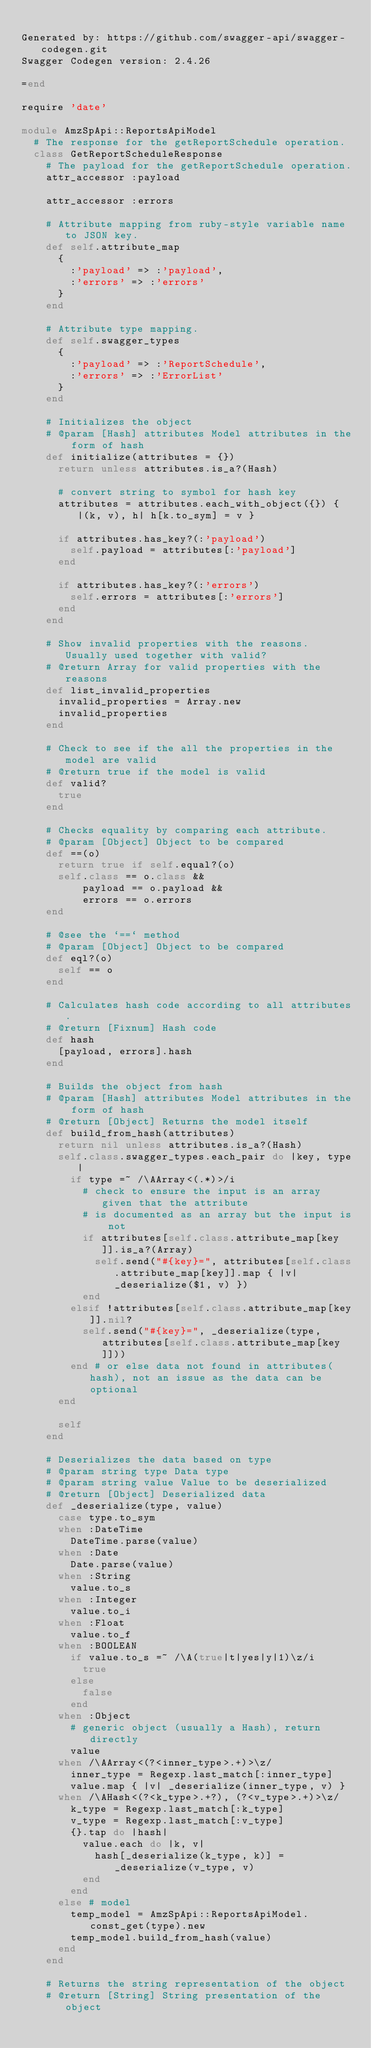Convert code to text. <code><loc_0><loc_0><loc_500><loc_500><_Ruby_>
Generated by: https://github.com/swagger-api/swagger-codegen.git
Swagger Codegen version: 2.4.26

=end

require 'date'

module AmzSpApi::ReportsApiModel
  # The response for the getReportSchedule operation.
  class GetReportScheduleResponse
    # The payload for the getReportSchedule operation.
    attr_accessor :payload

    attr_accessor :errors

    # Attribute mapping from ruby-style variable name to JSON key.
    def self.attribute_map
      {
        :'payload' => :'payload',
        :'errors' => :'errors'
      }
    end

    # Attribute type mapping.
    def self.swagger_types
      {
        :'payload' => :'ReportSchedule',
        :'errors' => :'ErrorList'
      }
    end

    # Initializes the object
    # @param [Hash] attributes Model attributes in the form of hash
    def initialize(attributes = {})
      return unless attributes.is_a?(Hash)

      # convert string to symbol for hash key
      attributes = attributes.each_with_object({}) { |(k, v), h| h[k.to_sym] = v }

      if attributes.has_key?(:'payload')
        self.payload = attributes[:'payload']
      end

      if attributes.has_key?(:'errors')
        self.errors = attributes[:'errors']
      end
    end

    # Show invalid properties with the reasons. Usually used together with valid?
    # @return Array for valid properties with the reasons
    def list_invalid_properties
      invalid_properties = Array.new
      invalid_properties
    end

    # Check to see if the all the properties in the model are valid
    # @return true if the model is valid
    def valid?
      true
    end

    # Checks equality by comparing each attribute.
    # @param [Object] Object to be compared
    def ==(o)
      return true if self.equal?(o)
      self.class == o.class &&
          payload == o.payload &&
          errors == o.errors
    end

    # @see the `==` method
    # @param [Object] Object to be compared
    def eql?(o)
      self == o
    end

    # Calculates hash code according to all attributes.
    # @return [Fixnum] Hash code
    def hash
      [payload, errors].hash
    end

    # Builds the object from hash
    # @param [Hash] attributes Model attributes in the form of hash
    # @return [Object] Returns the model itself
    def build_from_hash(attributes)
      return nil unless attributes.is_a?(Hash)
      self.class.swagger_types.each_pair do |key, type|
        if type =~ /\AArray<(.*)>/i
          # check to ensure the input is an array given that the attribute
          # is documented as an array but the input is not
          if attributes[self.class.attribute_map[key]].is_a?(Array)
            self.send("#{key}=", attributes[self.class.attribute_map[key]].map { |v| _deserialize($1, v) })
          end
        elsif !attributes[self.class.attribute_map[key]].nil?
          self.send("#{key}=", _deserialize(type, attributes[self.class.attribute_map[key]]))
        end # or else data not found in attributes(hash), not an issue as the data can be optional
      end

      self
    end

    # Deserializes the data based on type
    # @param string type Data type
    # @param string value Value to be deserialized
    # @return [Object] Deserialized data
    def _deserialize(type, value)
      case type.to_sym
      when :DateTime
        DateTime.parse(value)
      when :Date
        Date.parse(value)
      when :String
        value.to_s
      when :Integer
        value.to_i
      when :Float
        value.to_f
      when :BOOLEAN
        if value.to_s =~ /\A(true|t|yes|y|1)\z/i
          true
        else
          false
        end
      when :Object
        # generic object (usually a Hash), return directly
        value
      when /\AArray<(?<inner_type>.+)>\z/
        inner_type = Regexp.last_match[:inner_type]
        value.map { |v| _deserialize(inner_type, v) }
      when /\AHash<(?<k_type>.+?), (?<v_type>.+)>\z/
        k_type = Regexp.last_match[:k_type]
        v_type = Regexp.last_match[:v_type]
        {}.tap do |hash|
          value.each do |k, v|
            hash[_deserialize(k_type, k)] = _deserialize(v_type, v)
          end
        end
      else # model
        temp_model = AmzSpApi::ReportsApiModel.const_get(type).new
        temp_model.build_from_hash(value)
      end
    end

    # Returns the string representation of the object
    # @return [String] String presentation of the object</code> 